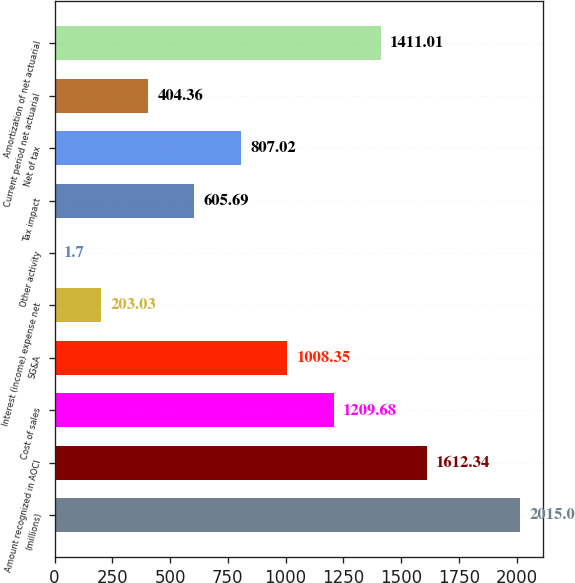<chart> <loc_0><loc_0><loc_500><loc_500><bar_chart><fcel>(millions)<fcel>Amount recognized in AOCI<fcel>Cost of sales<fcel>SG&A<fcel>Interest (income) expense net<fcel>Other activity<fcel>Tax impact<fcel>Net of tax<fcel>Current period net actuarial<fcel>Amortization of net actuarial<nl><fcel>2015<fcel>1612.34<fcel>1209.68<fcel>1008.35<fcel>203.03<fcel>1.7<fcel>605.69<fcel>807.02<fcel>404.36<fcel>1411.01<nl></chart> 